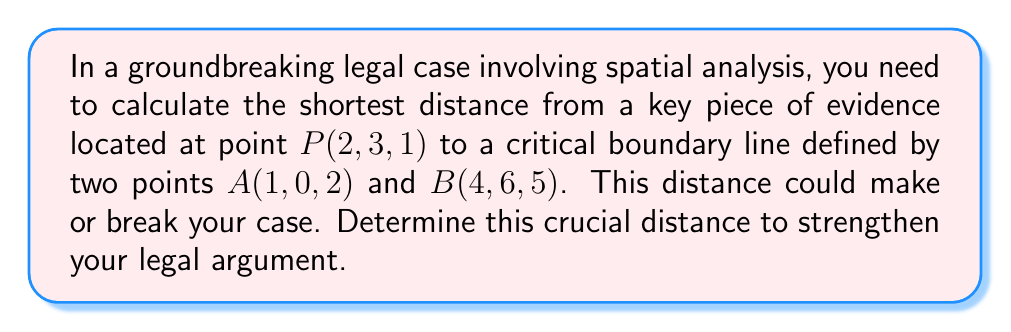Help me with this question. Let's approach this step-by-step:

1) First, we need to find the direction vector of the line. We can do this by subtracting the coordinates of point A from point B:
   $\vec{v} = B - A = (4-1, 6-0, 5-2) = (3, 6, 3)$

2) Now, we need a point on the line. We can use either A or B. Let's use A(1, 0, 2).

3) The vector from A to P is:
   $\vec{AP} = P - A = (2-1, 3-0, 1-2) = (1, 3, -1)$

4) The formula for the distance $d$ from a point to a line in 3D space is:

   $$d = \frac{|\vec{AP} \times \vec{v}|}{|\vec{v}|}$$

   where $\times$ denotes the cross product and $|...|$ denotes the magnitude of a vector.

5) Let's calculate the cross product $\vec{AP} \times \vec{v}$:
   $$\begin{vmatrix} 
   i & j & k \\
   1 & 3 & -1 \\
   3 & 6 & 3
   \end{vmatrix} = (3(3) - (-1)(6))i - (1(3) - (-1)(3))j + (1(6) - 3(3))k$$
   
   $= 9i + 6j - 3k$

6) The magnitude of this cross product is:
   $|\vec{AP} \times \vec{v}| = \sqrt{9^2 + 6^2 + (-3)^2} = \sqrt{126}$

7) The magnitude of $\vec{v}$ is:
   $|\vec{v}| = \sqrt{3^2 + 6^2 + 3^2} = \sqrt{54} = 3\sqrt{6}$

8) Now we can calculate the distance:
   $$d = \frac{\sqrt{126}}{3\sqrt{6}} = \frac{\sqrt{21}}{3}$$
Answer: $\frac{\sqrt{21}}{3}$ 